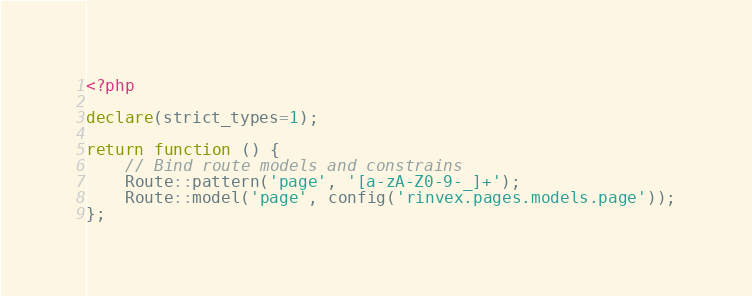<code> <loc_0><loc_0><loc_500><loc_500><_PHP_><?php

declare(strict_types=1);

return function () {
    // Bind route models and constrains
    Route::pattern('page', '[a-zA-Z0-9-_]+');
    Route::model('page', config('rinvex.pages.models.page'));
};
</code> 